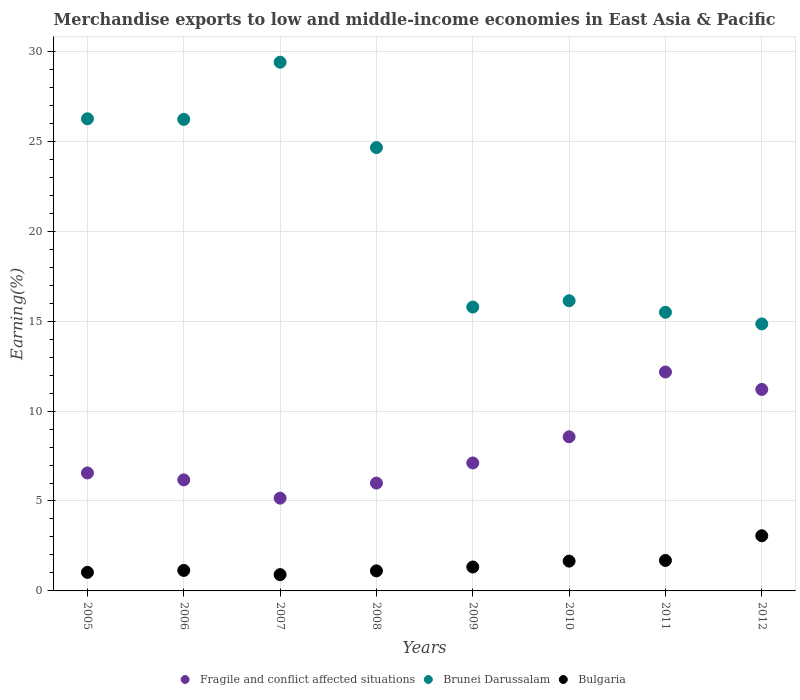How many different coloured dotlines are there?
Provide a succinct answer. 3. Is the number of dotlines equal to the number of legend labels?
Your answer should be very brief. Yes. What is the percentage of amount earned from merchandise exports in Fragile and conflict affected situations in 2011?
Keep it short and to the point. 12.17. Across all years, what is the maximum percentage of amount earned from merchandise exports in Bulgaria?
Your answer should be compact. 3.07. Across all years, what is the minimum percentage of amount earned from merchandise exports in Brunei Darussalam?
Make the answer very short. 14.84. In which year was the percentage of amount earned from merchandise exports in Fragile and conflict affected situations maximum?
Provide a short and direct response. 2011. In which year was the percentage of amount earned from merchandise exports in Fragile and conflict affected situations minimum?
Give a very brief answer. 2007. What is the total percentage of amount earned from merchandise exports in Bulgaria in the graph?
Offer a terse response. 11.94. What is the difference between the percentage of amount earned from merchandise exports in Bulgaria in 2006 and that in 2010?
Give a very brief answer. -0.52. What is the difference between the percentage of amount earned from merchandise exports in Brunei Darussalam in 2009 and the percentage of amount earned from merchandise exports in Fragile and conflict affected situations in 2010?
Your response must be concise. 7.21. What is the average percentage of amount earned from merchandise exports in Brunei Darussalam per year?
Give a very brief answer. 21.1. In the year 2005, what is the difference between the percentage of amount earned from merchandise exports in Bulgaria and percentage of amount earned from merchandise exports in Brunei Darussalam?
Your answer should be compact. -25.22. What is the ratio of the percentage of amount earned from merchandise exports in Brunei Darussalam in 2007 to that in 2011?
Offer a very short reply. 1.9. Is the difference between the percentage of amount earned from merchandise exports in Bulgaria in 2005 and 2006 greater than the difference between the percentage of amount earned from merchandise exports in Brunei Darussalam in 2005 and 2006?
Your answer should be very brief. No. What is the difference between the highest and the second highest percentage of amount earned from merchandise exports in Bulgaria?
Give a very brief answer. 1.37. What is the difference between the highest and the lowest percentage of amount earned from merchandise exports in Bulgaria?
Ensure brevity in your answer.  2.16. Is the sum of the percentage of amount earned from merchandise exports in Fragile and conflict affected situations in 2007 and 2010 greater than the maximum percentage of amount earned from merchandise exports in Bulgaria across all years?
Make the answer very short. Yes. Is it the case that in every year, the sum of the percentage of amount earned from merchandise exports in Bulgaria and percentage of amount earned from merchandise exports in Fragile and conflict affected situations  is greater than the percentage of amount earned from merchandise exports in Brunei Darussalam?
Make the answer very short. No. Is the percentage of amount earned from merchandise exports in Brunei Darussalam strictly greater than the percentage of amount earned from merchandise exports in Bulgaria over the years?
Your response must be concise. Yes. Is the percentage of amount earned from merchandise exports in Bulgaria strictly less than the percentage of amount earned from merchandise exports in Brunei Darussalam over the years?
Your answer should be compact. Yes. How many years are there in the graph?
Your answer should be very brief. 8. Are the values on the major ticks of Y-axis written in scientific E-notation?
Give a very brief answer. No. How many legend labels are there?
Your answer should be very brief. 3. What is the title of the graph?
Offer a very short reply. Merchandise exports to low and middle-income economies in East Asia & Pacific. Does "St. Kitts and Nevis" appear as one of the legend labels in the graph?
Your answer should be very brief. No. What is the label or title of the Y-axis?
Provide a short and direct response. Earning(%). What is the Earning(%) of Fragile and conflict affected situations in 2005?
Provide a short and direct response. 6.56. What is the Earning(%) in Brunei Darussalam in 2005?
Provide a short and direct response. 26.25. What is the Earning(%) of Bulgaria in 2005?
Your answer should be very brief. 1.03. What is the Earning(%) in Fragile and conflict affected situations in 2006?
Your answer should be very brief. 6.17. What is the Earning(%) of Brunei Darussalam in 2006?
Offer a very short reply. 26.22. What is the Earning(%) of Bulgaria in 2006?
Ensure brevity in your answer.  1.14. What is the Earning(%) in Fragile and conflict affected situations in 2007?
Offer a very short reply. 5.16. What is the Earning(%) in Brunei Darussalam in 2007?
Keep it short and to the point. 29.4. What is the Earning(%) in Bulgaria in 2007?
Offer a terse response. 0.91. What is the Earning(%) in Fragile and conflict affected situations in 2008?
Your answer should be compact. 6. What is the Earning(%) in Brunei Darussalam in 2008?
Provide a succinct answer. 24.65. What is the Earning(%) of Bulgaria in 2008?
Make the answer very short. 1.11. What is the Earning(%) in Fragile and conflict affected situations in 2009?
Make the answer very short. 7.12. What is the Earning(%) in Brunei Darussalam in 2009?
Your answer should be very brief. 15.78. What is the Earning(%) of Bulgaria in 2009?
Give a very brief answer. 1.33. What is the Earning(%) in Fragile and conflict affected situations in 2010?
Keep it short and to the point. 8.57. What is the Earning(%) of Brunei Darussalam in 2010?
Ensure brevity in your answer.  16.13. What is the Earning(%) in Bulgaria in 2010?
Make the answer very short. 1.66. What is the Earning(%) of Fragile and conflict affected situations in 2011?
Your answer should be very brief. 12.17. What is the Earning(%) of Brunei Darussalam in 2011?
Provide a succinct answer. 15.49. What is the Earning(%) of Bulgaria in 2011?
Provide a short and direct response. 1.69. What is the Earning(%) in Fragile and conflict affected situations in 2012?
Ensure brevity in your answer.  11.2. What is the Earning(%) in Brunei Darussalam in 2012?
Your answer should be very brief. 14.84. What is the Earning(%) of Bulgaria in 2012?
Provide a succinct answer. 3.07. Across all years, what is the maximum Earning(%) of Fragile and conflict affected situations?
Ensure brevity in your answer.  12.17. Across all years, what is the maximum Earning(%) in Brunei Darussalam?
Offer a terse response. 29.4. Across all years, what is the maximum Earning(%) of Bulgaria?
Give a very brief answer. 3.07. Across all years, what is the minimum Earning(%) in Fragile and conflict affected situations?
Offer a very short reply. 5.16. Across all years, what is the minimum Earning(%) of Brunei Darussalam?
Provide a succinct answer. 14.84. Across all years, what is the minimum Earning(%) of Bulgaria?
Ensure brevity in your answer.  0.91. What is the total Earning(%) of Fragile and conflict affected situations in the graph?
Offer a terse response. 62.94. What is the total Earning(%) of Brunei Darussalam in the graph?
Your response must be concise. 168.77. What is the total Earning(%) in Bulgaria in the graph?
Give a very brief answer. 11.94. What is the difference between the Earning(%) of Fragile and conflict affected situations in 2005 and that in 2006?
Offer a very short reply. 0.39. What is the difference between the Earning(%) in Brunei Darussalam in 2005 and that in 2006?
Your answer should be compact. 0.03. What is the difference between the Earning(%) of Bulgaria in 2005 and that in 2006?
Your answer should be very brief. -0.11. What is the difference between the Earning(%) in Fragile and conflict affected situations in 2005 and that in 2007?
Make the answer very short. 1.4. What is the difference between the Earning(%) in Brunei Darussalam in 2005 and that in 2007?
Provide a short and direct response. -3.15. What is the difference between the Earning(%) of Bulgaria in 2005 and that in 2007?
Provide a succinct answer. 0.13. What is the difference between the Earning(%) of Fragile and conflict affected situations in 2005 and that in 2008?
Ensure brevity in your answer.  0.56. What is the difference between the Earning(%) in Brunei Darussalam in 2005 and that in 2008?
Give a very brief answer. 1.6. What is the difference between the Earning(%) of Bulgaria in 2005 and that in 2008?
Keep it short and to the point. -0.08. What is the difference between the Earning(%) of Fragile and conflict affected situations in 2005 and that in 2009?
Provide a short and direct response. -0.56. What is the difference between the Earning(%) in Brunei Darussalam in 2005 and that in 2009?
Offer a very short reply. 10.47. What is the difference between the Earning(%) of Bulgaria in 2005 and that in 2009?
Ensure brevity in your answer.  -0.3. What is the difference between the Earning(%) in Fragile and conflict affected situations in 2005 and that in 2010?
Make the answer very short. -2.01. What is the difference between the Earning(%) in Brunei Darussalam in 2005 and that in 2010?
Make the answer very short. 10.12. What is the difference between the Earning(%) in Bulgaria in 2005 and that in 2010?
Your answer should be very brief. -0.62. What is the difference between the Earning(%) in Fragile and conflict affected situations in 2005 and that in 2011?
Your response must be concise. -5.61. What is the difference between the Earning(%) of Brunei Darussalam in 2005 and that in 2011?
Provide a short and direct response. 10.76. What is the difference between the Earning(%) of Bulgaria in 2005 and that in 2011?
Your answer should be very brief. -0.66. What is the difference between the Earning(%) in Fragile and conflict affected situations in 2005 and that in 2012?
Your answer should be very brief. -4.64. What is the difference between the Earning(%) of Brunei Darussalam in 2005 and that in 2012?
Your answer should be very brief. 11.41. What is the difference between the Earning(%) in Bulgaria in 2005 and that in 2012?
Offer a terse response. -2.03. What is the difference between the Earning(%) of Fragile and conflict affected situations in 2006 and that in 2007?
Offer a very short reply. 1.02. What is the difference between the Earning(%) in Brunei Darussalam in 2006 and that in 2007?
Your answer should be very brief. -3.18. What is the difference between the Earning(%) of Bulgaria in 2006 and that in 2007?
Provide a short and direct response. 0.23. What is the difference between the Earning(%) in Fragile and conflict affected situations in 2006 and that in 2008?
Make the answer very short. 0.18. What is the difference between the Earning(%) of Brunei Darussalam in 2006 and that in 2008?
Keep it short and to the point. 1.57. What is the difference between the Earning(%) in Bulgaria in 2006 and that in 2008?
Give a very brief answer. 0.03. What is the difference between the Earning(%) in Fragile and conflict affected situations in 2006 and that in 2009?
Provide a succinct answer. -0.94. What is the difference between the Earning(%) in Brunei Darussalam in 2006 and that in 2009?
Your answer should be very brief. 10.43. What is the difference between the Earning(%) in Bulgaria in 2006 and that in 2009?
Your response must be concise. -0.19. What is the difference between the Earning(%) in Fragile and conflict affected situations in 2006 and that in 2010?
Make the answer very short. -2.39. What is the difference between the Earning(%) of Brunei Darussalam in 2006 and that in 2010?
Give a very brief answer. 10.08. What is the difference between the Earning(%) of Bulgaria in 2006 and that in 2010?
Offer a terse response. -0.52. What is the difference between the Earning(%) in Fragile and conflict affected situations in 2006 and that in 2011?
Your answer should be very brief. -6. What is the difference between the Earning(%) in Brunei Darussalam in 2006 and that in 2011?
Ensure brevity in your answer.  10.72. What is the difference between the Earning(%) of Bulgaria in 2006 and that in 2011?
Offer a very short reply. -0.55. What is the difference between the Earning(%) in Fragile and conflict affected situations in 2006 and that in 2012?
Your response must be concise. -5.03. What is the difference between the Earning(%) in Brunei Darussalam in 2006 and that in 2012?
Make the answer very short. 11.37. What is the difference between the Earning(%) in Bulgaria in 2006 and that in 2012?
Make the answer very short. -1.93. What is the difference between the Earning(%) of Fragile and conflict affected situations in 2007 and that in 2008?
Make the answer very short. -0.84. What is the difference between the Earning(%) of Brunei Darussalam in 2007 and that in 2008?
Your answer should be very brief. 4.75. What is the difference between the Earning(%) of Bulgaria in 2007 and that in 2008?
Offer a terse response. -0.21. What is the difference between the Earning(%) in Fragile and conflict affected situations in 2007 and that in 2009?
Offer a very short reply. -1.96. What is the difference between the Earning(%) of Brunei Darussalam in 2007 and that in 2009?
Offer a very short reply. 13.61. What is the difference between the Earning(%) in Bulgaria in 2007 and that in 2009?
Provide a short and direct response. -0.42. What is the difference between the Earning(%) in Fragile and conflict affected situations in 2007 and that in 2010?
Your answer should be very brief. -3.41. What is the difference between the Earning(%) of Brunei Darussalam in 2007 and that in 2010?
Give a very brief answer. 13.26. What is the difference between the Earning(%) in Bulgaria in 2007 and that in 2010?
Your answer should be compact. -0.75. What is the difference between the Earning(%) of Fragile and conflict affected situations in 2007 and that in 2011?
Your response must be concise. -7.01. What is the difference between the Earning(%) of Brunei Darussalam in 2007 and that in 2011?
Give a very brief answer. 13.9. What is the difference between the Earning(%) of Bulgaria in 2007 and that in 2011?
Make the answer very short. -0.79. What is the difference between the Earning(%) in Fragile and conflict affected situations in 2007 and that in 2012?
Provide a succinct answer. -6.04. What is the difference between the Earning(%) of Brunei Darussalam in 2007 and that in 2012?
Give a very brief answer. 14.55. What is the difference between the Earning(%) in Bulgaria in 2007 and that in 2012?
Your response must be concise. -2.16. What is the difference between the Earning(%) of Fragile and conflict affected situations in 2008 and that in 2009?
Give a very brief answer. -1.12. What is the difference between the Earning(%) in Brunei Darussalam in 2008 and that in 2009?
Make the answer very short. 8.87. What is the difference between the Earning(%) in Bulgaria in 2008 and that in 2009?
Provide a short and direct response. -0.22. What is the difference between the Earning(%) in Fragile and conflict affected situations in 2008 and that in 2010?
Make the answer very short. -2.57. What is the difference between the Earning(%) in Brunei Darussalam in 2008 and that in 2010?
Make the answer very short. 8.51. What is the difference between the Earning(%) in Bulgaria in 2008 and that in 2010?
Provide a succinct answer. -0.54. What is the difference between the Earning(%) of Fragile and conflict affected situations in 2008 and that in 2011?
Ensure brevity in your answer.  -6.18. What is the difference between the Earning(%) of Brunei Darussalam in 2008 and that in 2011?
Make the answer very short. 9.16. What is the difference between the Earning(%) in Bulgaria in 2008 and that in 2011?
Provide a succinct answer. -0.58. What is the difference between the Earning(%) of Fragile and conflict affected situations in 2008 and that in 2012?
Ensure brevity in your answer.  -5.21. What is the difference between the Earning(%) in Brunei Darussalam in 2008 and that in 2012?
Make the answer very short. 9.8. What is the difference between the Earning(%) in Bulgaria in 2008 and that in 2012?
Your response must be concise. -1.95. What is the difference between the Earning(%) of Fragile and conflict affected situations in 2009 and that in 2010?
Ensure brevity in your answer.  -1.45. What is the difference between the Earning(%) in Brunei Darussalam in 2009 and that in 2010?
Ensure brevity in your answer.  -0.35. What is the difference between the Earning(%) of Bulgaria in 2009 and that in 2010?
Your response must be concise. -0.33. What is the difference between the Earning(%) of Fragile and conflict affected situations in 2009 and that in 2011?
Offer a terse response. -5.06. What is the difference between the Earning(%) of Brunei Darussalam in 2009 and that in 2011?
Your answer should be compact. 0.29. What is the difference between the Earning(%) of Bulgaria in 2009 and that in 2011?
Keep it short and to the point. -0.36. What is the difference between the Earning(%) of Fragile and conflict affected situations in 2009 and that in 2012?
Keep it short and to the point. -4.09. What is the difference between the Earning(%) in Brunei Darussalam in 2009 and that in 2012?
Offer a terse response. 0.94. What is the difference between the Earning(%) in Bulgaria in 2009 and that in 2012?
Keep it short and to the point. -1.74. What is the difference between the Earning(%) in Fragile and conflict affected situations in 2010 and that in 2011?
Give a very brief answer. -3.6. What is the difference between the Earning(%) in Brunei Darussalam in 2010 and that in 2011?
Your answer should be compact. 0.64. What is the difference between the Earning(%) of Bulgaria in 2010 and that in 2011?
Make the answer very short. -0.04. What is the difference between the Earning(%) of Fragile and conflict affected situations in 2010 and that in 2012?
Your answer should be very brief. -2.63. What is the difference between the Earning(%) of Brunei Darussalam in 2010 and that in 2012?
Your response must be concise. 1.29. What is the difference between the Earning(%) of Bulgaria in 2010 and that in 2012?
Your answer should be very brief. -1.41. What is the difference between the Earning(%) of Fragile and conflict affected situations in 2011 and that in 2012?
Keep it short and to the point. 0.97. What is the difference between the Earning(%) in Brunei Darussalam in 2011 and that in 2012?
Keep it short and to the point. 0.65. What is the difference between the Earning(%) in Bulgaria in 2011 and that in 2012?
Offer a terse response. -1.37. What is the difference between the Earning(%) in Fragile and conflict affected situations in 2005 and the Earning(%) in Brunei Darussalam in 2006?
Offer a terse response. -19.66. What is the difference between the Earning(%) in Fragile and conflict affected situations in 2005 and the Earning(%) in Bulgaria in 2006?
Provide a short and direct response. 5.42. What is the difference between the Earning(%) of Brunei Darussalam in 2005 and the Earning(%) of Bulgaria in 2006?
Offer a very short reply. 25.11. What is the difference between the Earning(%) in Fragile and conflict affected situations in 2005 and the Earning(%) in Brunei Darussalam in 2007?
Offer a very short reply. -22.84. What is the difference between the Earning(%) in Fragile and conflict affected situations in 2005 and the Earning(%) in Bulgaria in 2007?
Provide a short and direct response. 5.65. What is the difference between the Earning(%) of Brunei Darussalam in 2005 and the Earning(%) of Bulgaria in 2007?
Provide a short and direct response. 25.35. What is the difference between the Earning(%) in Fragile and conflict affected situations in 2005 and the Earning(%) in Brunei Darussalam in 2008?
Provide a short and direct response. -18.09. What is the difference between the Earning(%) in Fragile and conflict affected situations in 2005 and the Earning(%) in Bulgaria in 2008?
Make the answer very short. 5.44. What is the difference between the Earning(%) in Brunei Darussalam in 2005 and the Earning(%) in Bulgaria in 2008?
Give a very brief answer. 25.14. What is the difference between the Earning(%) of Fragile and conflict affected situations in 2005 and the Earning(%) of Brunei Darussalam in 2009?
Your answer should be compact. -9.22. What is the difference between the Earning(%) in Fragile and conflict affected situations in 2005 and the Earning(%) in Bulgaria in 2009?
Your answer should be compact. 5.23. What is the difference between the Earning(%) in Brunei Darussalam in 2005 and the Earning(%) in Bulgaria in 2009?
Provide a short and direct response. 24.92. What is the difference between the Earning(%) in Fragile and conflict affected situations in 2005 and the Earning(%) in Brunei Darussalam in 2010?
Keep it short and to the point. -9.57. What is the difference between the Earning(%) of Fragile and conflict affected situations in 2005 and the Earning(%) of Bulgaria in 2010?
Your response must be concise. 4.9. What is the difference between the Earning(%) of Brunei Darussalam in 2005 and the Earning(%) of Bulgaria in 2010?
Ensure brevity in your answer.  24.59. What is the difference between the Earning(%) of Fragile and conflict affected situations in 2005 and the Earning(%) of Brunei Darussalam in 2011?
Provide a short and direct response. -8.93. What is the difference between the Earning(%) of Fragile and conflict affected situations in 2005 and the Earning(%) of Bulgaria in 2011?
Your response must be concise. 4.87. What is the difference between the Earning(%) in Brunei Darussalam in 2005 and the Earning(%) in Bulgaria in 2011?
Ensure brevity in your answer.  24.56. What is the difference between the Earning(%) in Fragile and conflict affected situations in 2005 and the Earning(%) in Brunei Darussalam in 2012?
Make the answer very short. -8.29. What is the difference between the Earning(%) in Fragile and conflict affected situations in 2005 and the Earning(%) in Bulgaria in 2012?
Your answer should be compact. 3.49. What is the difference between the Earning(%) of Brunei Darussalam in 2005 and the Earning(%) of Bulgaria in 2012?
Give a very brief answer. 23.18. What is the difference between the Earning(%) of Fragile and conflict affected situations in 2006 and the Earning(%) of Brunei Darussalam in 2007?
Your answer should be compact. -23.22. What is the difference between the Earning(%) in Fragile and conflict affected situations in 2006 and the Earning(%) in Bulgaria in 2007?
Offer a very short reply. 5.27. What is the difference between the Earning(%) of Brunei Darussalam in 2006 and the Earning(%) of Bulgaria in 2007?
Keep it short and to the point. 25.31. What is the difference between the Earning(%) of Fragile and conflict affected situations in 2006 and the Earning(%) of Brunei Darussalam in 2008?
Offer a terse response. -18.47. What is the difference between the Earning(%) in Fragile and conflict affected situations in 2006 and the Earning(%) in Bulgaria in 2008?
Offer a very short reply. 5.06. What is the difference between the Earning(%) of Brunei Darussalam in 2006 and the Earning(%) of Bulgaria in 2008?
Your answer should be compact. 25.1. What is the difference between the Earning(%) of Fragile and conflict affected situations in 2006 and the Earning(%) of Brunei Darussalam in 2009?
Your answer should be compact. -9.61. What is the difference between the Earning(%) in Fragile and conflict affected situations in 2006 and the Earning(%) in Bulgaria in 2009?
Keep it short and to the point. 4.84. What is the difference between the Earning(%) of Brunei Darussalam in 2006 and the Earning(%) of Bulgaria in 2009?
Offer a very short reply. 24.89. What is the difference between the Earning(%) of Fragile and conflict affected situations in 2006 and the Earning(%) of Brunei Darussalam in 2010?
Your answer should be very brief. -9.96. What is the difference between the Earning(%) of Fragile and conflict affected situations in 2006 and the Earning(%) of Bulgaria in 2010?
Your answer should be very brief. 4.52. What is the difference between the Earning(%) of Brunei Darussalam in 2006 and the Earning(%) of Bulgaria in 2010?
Provide a short and direct response. 24.56. What is the difference between the Earning(%) in Fragile and conflict affected situations in 2006 and the Earning(%) in Brunei Darussalam in 2011?
Your answer should be compact. -9.32. What is the difference between the Earning(%) in Fragile and conflict affected situations in 2006 and the Earning(%) in Bulgaria in 2011?
Your answer should be very brief. 4.48. What is the difference between the Earning(%) of Brunei Darussalam in 2006 and the Earning(%) of Bulgaria in 2011?
Your response must be concise. 24.52. What is the difference between the Earning(%) in Fragile and conflict affected situations in 2006 and the Earning(%) in Brunei Darussalam in 2012?
Ensure brevity in your answer.  -8.67. What is the difference between the Earning(%) in Fragile and conflict affected situations in 2006 and the Earning(%) in Bulgaria in 2012?
Your answer should be compact. 3.11. What is the difference between the Earning(%) in Brunei Darussalam in 2006 and the Earning(%) in Bulgaria in 2012?
Make the answer very short. 23.15. What is the difference between the Earning(%) of Fragile and conflict affected situations in 2007 and the Earning(%) of Brunei Darussalam in 2008?
Provide a short and direct response. -19.49. What is the difference between the Earning(%) of Fragile and conflict affected situations in 2007 and the Earning(%) of Bulgaria in 2008?
Offer a very short reply. 4.04. What is the difference between the Earning(%) of Brunei Darussalam in 2007 and the Earning(%) of Bulgaria in 2008?
Provide a short and direct response. 28.28. What is the difference between the Earning(%) of Fragile and conflict affected situations in 2007 and the Earning(%) of Brunei Darussalam in 2009?
Your answer should be compact. -10.62. What is the difference between the Earning(%) of Fragile and conflict affected situations in 2007 and the Earning(%) of Bulgaria in 2009?
Your response must be concise. 3.83. What is the difference between the Earning(%) in Brunei Darussalam in 2007 and the Earning(%) in Bulgaria in 2009?
Make the answer very short. 28.07. What is the difference between the Earning(%) of Fragile and conflict affected situations in 2007 and the Earning(%) of Brunei Darussalam in 2010?
Ensure brevity in your answer.  -10.98. What is the difference between the Earning(%) in Fragile and conflict affected situations in 2007 and the Earning(%) in Bulgaria in 2010?
Your answer should be compact. 3.5. What is the difference between the Earning(%) of Brunei Darussalam in 2007 and the Earning(%) of Bulgaria in 2010?
Offer a very short reply. 27.74. What is the difference between the Earning(%) in Fragile and conflict affected situations in 2007 and the Earning(%) in Brunei Darussalam in 2011?
Offer a very short reply. -10.33. What is the difference between the Earning(%) of Fragile and conflict affected situations in 2007 and the Earning(%) of Bulgaria in 2011?
Give a very brief answer. 3.46. What is the difference between the Earning(%) in Brunei Darussalam in 2007 and the Earning(%) in Bulgaria in 2011?
Your response must be concise. 27.7. What is the difference between the Earning(%) of Fragile and conflict affected situations in 2007 and the Earning(%) of Brunei Darussalam in 2012?
Make the answer very short. -9.69. What is the difference between the Earning(%) in Fragile and conflict affected situations in 2007 and the Earning(%) in Bulgaria in 2012?
Provide a short and direct response. 2.09. What is the difference between the Earning(%) in Brunei Darussalam in 2007 and the Earning(%) in Bulgaria in 2012?
Keep it short and to the point. 26.33. What is the difference between the Earning(%) in Fragile and conflict affected situations in 2008 and the Earning(%) in Brunei Darussalam in 2009?
Provide a short and direct response. -9.79. What is the difference between the Earning(%) of Fragile and conflict affected situations in 2008 and the Earning(%) of Bulgaria in 2009?
Make the answer very short. 4.67. What is the difference between the Earning(%) of Brunei Darussalam in 2008 and the Earning(%) of Bulgaria in 2009?
Your answer should be compact. 23.32. What is the difference between the Earning(%) of Fragile and conflict affected situations in 2008 and the Earning(%) of Brunei Darussalam in 2010?
Offer a terse response. -10.14. What is the difference between the Earning(%) of Fragile and conflict affected situations in 2008 and the Earning(%) of Bulgaria in 2010?
Keep it short and to the point. 4.34. What is the difference between the Earning(%) in Brunei Darussalam in 2008 and the Earning(%) in Bulgaria in 2010?
Make the answer very short. 22.99. What is the difference between the Earning(%) of Fragile and conflict affected situations in 2008 and the Earning(%) of Brunei Darussalam in 2011?
Your response must be concise. -9.5. What is the difference between the Earning(%) of Fragile and conflict affected situations in 2008 and the Earning(%) of Bulgaria in 2011?
Ensure brevity in your answer.  4.3. What is the difference between the Earning(%) in Brunei Darussalam in 2008 and the Earning(%) in Bulgaria in 2011?
Make the answer very short. 22.95. What is the difference between the Earning(%) of Fragile and conflict affected situations in 2008 and the Earning(%) of Brunei Darussalam in 2012?
Your answer should be compact. -8.85. What is the difference between the Earning(%) of Fragile and conflict affected situations in 2008 and the Earning(%) of Bulgaria in 2012?
Make the answer very short. 2.93. What is the difference between the Earning(%) in Brunei Darussalam in 2008 and the Earning(%) in Bulgaria in 2012?
Your response must be concise. 21.58. What is the difference between the Earning(%) in Fragile and conflict affected situations in 2009 and the Earning(%) in Brunei Darussalam in 2010?
Make the answer very short. -9.02. What is the difference between the Earning(%) in Fragile and conflict affected situations in 2009 and the Earning(%) in Bulgaria in 2010?
Make the answer very short. 5.46. What is the difference between the Earning(%) of Brunei Darussalam in 2009 and the Earning(%) of Bulgaria in 2010?
Make the answer very short. 14.13. What is the difference between the Earning(%) in Fragile and conflict affected situations in 2009 and the Earning(%) in Brunei Darussalam in 2011?
Your answer should be very brief. -8.38. What is the difference between the Earning(%) in Fragile and conflict affected situations in 2009 and the Earning(%) in Bulgaria in 2011?
Keep it short and to the point. 5.42. What is the difference between the Earning(%) in Brunei Darussalam in 2009 and the Earning(%) in Bulgaria in 2011?
Provide a short and direct response. 14.09. What is the difference between the Earning(%) in Fragile and conflict affected situations in 2009 and the Earning(%) in Brunei Darussalam in 2012?
Your response must be concise. -7.73. What is the difference between the Earning(%) in Fragile and conflict affected situations in 2009 and the Earning(%) in Bulgaria in 2012?
Offer a very short reply. 4.05. What is the difference between the Earning(%) in Brunei Darussalam in 2009 and the Earning(%) in Bulgaria in 2012?
Make the answer very short. 12.72. What is the difference between the Earning(%) of Fragile and conflict affected situations in 2010 and the Earning(%) of Brunei Darussalam in 2011?
Your answer should be compact. -6.92. What is the difference between the Earning(%) of Fragile and conflict affected situations in 2010 and the Earning(%) of Bulgaria in 2011?
Provide a short and direct response. 6.87. What is the difference between the Earning(%) of Brunei Darussalam in 2010 and the Earning(%) of Bulgaria in 2011?
Your response must be concise. 14.44. What is the difference between the Earning(%) in Fragile and conflict affected situations in 2010 and the Earning(%) in Brunei Darussalam in 2012?
Make the answer very short. -6.28. What is the difference between the Earning(%) in Fragile and conflict affected situations in 2010 and the Earning(%) in Bulgaria in 2012?
Make the answer very short. 5.5. What is the difference between the Earning(%) of Brunei Darussalam in 2010 and the Earning(%) of Bulgaria in 2012?
Keep it short and to the point. 13.07. What is the difference between the Earning(%) in Fragile and conflict affected situations in 2011 and the Earning(%) in Brunei Darussalam in 2012?
Offer a very short reply. -2.67. What is the difference between the Earning(%) of Fragile and conflict affected situations in 2011 and the Earning(%) of Bulgaria in 2012?
Make the answer very short. 9.1. What is the difference between the Earning(%) in Brunei Darussalam in 2011 and the Earning(%) in Bulgaria in 2012?
Ensure brevity in your answer.  12.42. What is the average Earning(%) of Fragile and conflict affected situations per year?
Provide a short and direct response. 7.87. What is the average Earning(%) of Brunei Darussalam per year?
Ensure brevity in your answer.  21.1. What is the average Earning(%) in Bulgaria per year?
Offer a terse response. 1.49. In the year 2005, what is the difference between the Earning(%) in Fragile and conflict affected situations and Earning(%) in Brunei Darussalam?
Give a very brief answer. -19.69. In the year 2005, what is the difference between the Earning(%) of Fragile and conflict affected situations and Earning(%) of Bulgaria?
Make the answer very short. 5.53. In the year 2005, what is the difference between the Earning(%) of Brunei Darussalam and Earning(%) of Bulgaria?
Keep it short and to the point. 25.22. In the year 2006, what is the difference between the Earning(%) in Fragile and conflict affected situations and Earning(%) in Brunei Darussalam?
Make the answer very short. -20.04. In the year 2006, what is the difference between the Earning(%) in Fragile and conflict affected situations and Earning(%) in Bulgaria?
Offer a terse response. 5.03. In the year 2006, what is the difference between the Earning(%) of Brunei Darussalam and Earning(%) of Bulgaria?
Provide a succinct answer. 25.08. In the year 2007, what is the difference between the Earning(%) in Fragile and conflict affected situations and Earning(%) in Brunei Darussalam?
Ensure brevity in your answer.  -24.24. In the year 2007, what is the difference between the Earning(%) of Fragile and conflict affected situations and Earning(%) of Bulgaria?
Your answer should be very brief. 4.25. In the year 2007, what is the difference between the Earning(%) in Brunei Darussalam and Earning(%) in Bulgaria?
Ensure brevity in your answer.  28.49. In the year 2008, what is the difference between the Earning(%) in Fragile and conflict affected situations and Earning(%) in Brunei Darussalam?
Offer a terse response. -18.65. In the year 2008, what is the difference between the Earning(%) of Fragile and conflict affected situations and Earning(%) of Bulgaria?
Your response must be concise. 4.88. In the year 2008, what is the difference between the Earning(%) in Brunei Darussalam and Earning(%) in Bulgaria?
Provide a succinct answer. 23.53. In the year 2009, what is the difference between the Earning(%) of Fragile and conflict affected situations and Earning(%) of Brunei Darussalam?
Keep it short and to the point. -8.67. In the year 2009, what is the difference between the Earning(%) in Fragile and conflict affected situations and Earning(%) in Bulgaria?
Ensure brevity in your answer.  5.79. In the year 2009, what is the difference between the Earning(%) in Brunei Darussalam and Earning(%) in Bulgaria?
Your answer should be very brief. 14.45. In the year 2010, what is the difference between the Earning(%) in Fragile and conflict affected situations and Earning(%) in Brunei Darussalam?
Offer a very short reply. -7.57. In the year 2010, what is the difference between the Earning(%) in Fragile and conflict affected situations and Earning(%) in Bulgaria?
Provide a short and direct response. 6.91. In the year 2010, what is the difference between the Earning(%) of Brunei Darussalam and Earning(%) of Bulgaria?
Your response must be concise. 14.48. In the year 2011, what is the difference between the Earning(%) in Fragile and conflict affected situations and Earning(%) in Brunei Darussalam?
Offer a very short reply. -3.32. In the year 2011, what is the difference between the Earning(%) in Fragile and conflict affected situations and Earning(%) in Bulgaria?
Keep it short and to the point. 10.48. In the year 2011, what is the difference between the Earning(%) of Brunei Darussalam and Earning(%) of Bulgaria?
Provide a succinct answer. 13.8. In the year 2012, what is the difference between the Earning(%) in Fragile and conflict affected situations and Earning(%) in Brunei Darussalam?
Your response must be concise. -3.64. In the year 2012, what is the difference between the Earning(%) of Fragile and conflict affected situations and Earning(%) of Bulgaria?
Keep it short and to the point. 8.13. In the year 2012, what is the difference between the Earning(%) of Brunei Darussalam and Earning(%) of Bulgaria?
Make the answer very short. 11.78. What is the ratio of the Earning(%) in Fragile and conflict affected situations in 2005 to that in 2006?
Offer a terse response. 1.06. What is the ratio of the Earning(%) in Bulgaria in 2005 to that in 2006?
Keep it short and to the point. 0.91. What is the ratio of the Earning(%) in Fragile and conflict affected situations in 2005 to that in 2007?
Your answer should be compact. 1.27. What is the ratio of the Earning(%) of Brunei Darussalam in 2005 to that in 2007?
Provide a short and direct response. 0.89. What is the ratio of the Earning(%) in Bulgaria in 2005 to that in 2007?
Make the answer very short. 1.14. What is the ratio of the Earning(%) of Fragile and conflict affected situations in 2005 to that in 2008?
Keep it short and to the point. 1.09. What is the ratio of the Earning(%) of Brunei Darussalam in 2005 to that in 2008?
Provide a succinct answer. 1.06. What is the ratio of the Earning(%) in Bulgaria in 2005 to that in 2008?
Offer a terse response. 0.93. What is the ratio of the Earning(%) of Fragile and conflict affected situations in 2005 to that in 2009?
Your answer should be compact. 0.92. What is the ratio of the Earning(%) in Brunei Darussalam in 2005 to that in 2009?
Provide a succinct answer. 1.66. What is the ratio of the Earning(%) of Bulgaria in 2005 to that in 2009?
Make the answer very short. 0.78. What is the ratio of the Earning(%) in Fragile and conflict affected situations in 2005 to that in 2010?
Offer a terse response. 0.77. What is the ratio of the Earning(%) of Brunei Darussalam in 2005 to that in 2010?
Make the answer very short. 1.63. What is the ratio of the Earning(%) in Bulgaria in 2005 to that in 2010?
Provide a short and direct response. 0.62. What is the ratio of the Earning(%) of Fragile and conflict affected situations in 2005 to that in 2011?
Make the answer very short. 0.54. What is the ratio of the Earning(%) in Brunei Darussalam in 2005 to that in 2011?
Your answer should be very brief. 1.69. What is the ratio of the Earning(%) of Bulgaria in 2005 to that in 2011?
Your answer should be very brief. 0.61. What is the ratio of the Earning(%) of Fragile and conflict affected situations in 2005 to that in 2012?
Your answer should be compact. 0.59. What is the ratio of the Earning(%) of Brunei Darussalam in 2005 to that in 2012?
Give a very brief answer. 1.77. What is the ratio of the Earning(%) in Bulgaria in 2005 to that in 2012?
Keep it short and to the point. 0.34. What is the ratio of the Earning(%) in Fragile and conflict affected situations in 2006 to that in 2007?
Make the answer very short. 1.2. What is the ratio of the Earning(%) of Brunei Darussalam in 2006 to that in 2007?
Your answer should be compact. 0.89. What is the ratio of the Earning(%) in Bulgaria in 2006 to that in 2007?
Provide a short and direct response. 1.26. What is the ratio of the Earning(%) in Fragile and conflict affected situations in 2006 to that in 2008?
Your response must be concise. 1.03. What is the ratio of the Earning(%) of Brunei Darussalam in 2006 to that in 2008?
Give a very brief answer. 1.06. What is the ratio of the Earning(%) in Bulgaria in 2006 to that in 2008?
Ensure brevity in your answer.  1.02. What is the ratio of the Earning(%) in Fragile and conflict affected situations in 2006 to that in 2009?
Your answer should be very brief. 0.87. What is the ratio of the Earning(%) of Brunei Darussalam in 2006 to that in 2009?
Provide a succinct answer. 1.66. What is the ratio of the Earning(%) in Bulgaria in 2006 to that in 2009?
Offer a very short reply. 0.86. What is the ratio of the Earning(%) of Fragile and conflict affected situations in 2006 to that in 2010?
Your answer should be compact. 0.72. What is the ratio of the Earning(%) in Brunei Darussalam in 2006 to that in 2010?
Offer a terse response. 1.62. What is the ratio of the Earning(%) in Bulgaria in 2006 to that in 2010?
Your answer should be compact. 0.69. What is the ratio of the Earning(%) in Fragile and conflict affected situations in 2006 to that in 2011?
Give a very brief answer. 0.51. What is the ratio of the Earning(%) in Brunei Darussalam in 2006 to that in 2011?
Make the answer very short. 1.69. What is the ratio of the Earning(%) of Bulgaria in 2006 to that in 2011?
Offer a very short reply. 0.67. What is the ratio of the Earning(%) of Fragile and conflict affected situations in 2006 to that in 2012?
Provide a short and direct response. 0.55. What is the ratio of the Earning(%) in Brunei Darussalam in 2006 to that in 2012?
Your response must be concise. 1.77. What is the ratio of the Earning(%) of Bulgaria in 2006 to that in 2012?
Ensure brevity in your answer.  0.37. What is the ratio of the Earning(%) of Fragile and conflict affected situations in 2007 to that in 2008?
Your answer should be compact. 0.86. What is the ratio of the Earning(%) in Brunei Darussalam in 2007 to that in 2008?
Ensure brevity in your answer.  1.19. What is the ratio of the Earning(%) of Bulgaria in 2007 to that in 2008?
Make the answer very short. 0.81. What is the ratio of the Earning(%) in Fragile and conflict affected situations in 2007 to that in 2009?
Make the answer very short. 0.72. What is the ratio of the Earning(%) in Brunei Darussalam in 2007 to that in 2009?
Provide a succinct answer. 1.86. What is the ratio of the Earning(%) in Bulgaria in 2007 to that in 2009?
Keep it short and to the point. 0.68. What is the ratio of the Earning(%) of Fragile and conflict affected situations in 2007 to that in 2010?
Make the answer very short. 0.6. What is the ratio of the Earning(%) of Brunei Darussalam in 2007 to that in 2010?
Provide a short and direct response. 1.82. What is the ratio of the Earning(%) in Bulgaria in 2007 to that in 2010?
Your answer should be compact. 0.55. What is the ratio of the Earning(%) in Fragile and conflict affected situations in 2007 to that in 2011?
Your answer should be compact. 0.42. What is the ratio of the Earning(%) in Brunei Darussalam in 2007 to that in 2011?
Offer a terse response. 1.9. What is the ratio of the Earning(%) of Bulgaria in 2007 to that in 2011?
Your answer should be very brief. 0.53. What is the ratio of the Earning(%) of Fragile and conflict affected situations in 2007 to that in 2012?
Provide a succinct answer. 0.46. What is the ratio of the Earning(%) of Brunei Darussalam in 2007 to that in 2012?
Provide a succinct answer. 1.98. What is the ratio of the Earning(%) in Bulgaria in 2007 to that in 2012?
Keep it short and to the point. 0.3. What is the ratio of the Earning(%) of Fragile and conflict affected situations in 2008 to that in 2009?
Give a very brief answer. 0.84. What is the ratio of the Earning(%) in Brunei Darussalam in 2008 to that in 2009?
Provide a short and direct response. 1.56. What is the ratio of the Earning(%) in Bulgaria in 2008 to that in 2009?
Make the answer very short. 0.84. What is the ratio of the Earning(%) of Fragile and conflict affected situations in 2008 to that in 2010?
Offer a terse response. 0.7. What is the ratio of the Earning(%) in Brunei Darussalam in 2008 to that in 2010?
Make the answer very short. 1.53. What is the ratio of the Earning(%) in Bulgaria in 2008 to that in 2010?
Your answer should be compact. 0.67. What is the ratio of the Earning(%) in Fragile and conflict affected situations in 2008 to that in 2011?
Your response must be concise. 0.49. What is the ratio of the Earning(%) of Brunei Darussalam in 2008 to that in 2011?
Ensure brevity in your answer.  1.59. What is the ratio of the Earning(%) of Bulgaria in 2008 to that in 2011?
Your answer should be very brief. 0.66. What is the ratio of the Earning(%) of Fragile and conflict affected situations in 2008 to that in 2012?
Offer a very short reply. 0.54. What is the ratio of the Earning(%) in Brunei Darussalam in 2008 to that in 2012?
Keep it short and to the point. 1.66. What is the ratio of the Earning(%) of Bulgaria in 2008 to that in 2012?
Provide a succinct answer. 0.36. What is the ratio of the Earning(%) of Fragile and conflict affected situations in 2009 to that in 2010?
Your answer should be very brief. 0.83. What is the ratio of the Earning(%) of Brunei Darussalam in 2009 to that in 2010?
Keep it short and to the point. 0.98. What is the ratio of the Earning(%) in Bulgaria in 2009 to that in 2010?
Your answer should be compact. 0.8. What is the ratio of the Earning(%) of Fragile and conflict affected situations in 2009 to that in 2011?
Make the answer very short. 0.58. What is the ratio of the Earning(%) in Brunei Darussalam in 2009 to that in 2011?
Offer a terse response. 1.02. What is the ratio of the Earning(%) in Bulgaria in 2009 to that in 2011?
Offer a very short reply. 0.79. What is the ratio of the Earning(%) of Fragile and conflict affected situations in 2009 to that in 2012?
Give a very brief answer. 0.64. What is the ratio of the Earning(%) in Brunei Darussalam in 2009 to that in 2012?
Make the answer very short. 1.06. What is the ratio of the Earning(%) of Bulgaria in 2009 to that in 2012?
Offer a very short reply. 0.43. What is the ratio of the Earning(%) of Fragile and conflict affected situations in 2010 to that in 2011?
Your response must be concise. 0.7. What is the ratio of the Earning(%) in Brunei Darussalam in 2010 to that in 2011?
Keep it short and to the point. 1.04. What is the ratio of the Earning(%) of Bulgaria in 2010 to that in 2011?
Provide a short and direct response. 0.98. What is the ratio of the Earning(%) of Fragile and conflict affected situations in 2010 to that in 2012?
Provide a short and direct response. 0.76. What is the ratio of the Earning(%) in Brunei Darussalam in 2010 to that in 2012?
Provide a succinct answer. 1.09. What is the ratio of the Earning(%) of Bulgaria in 2010 to that in 2012?
Keep it short and to the point. 0.54. What is the ratio of the Earning(%) of Fragile and conflict affected situations in 2011 to that in 2012?
Ensure brevity in your answer.  1.09. What is the ratio of the Earning(%) of Brunei Darussalam in 2011 to that in 2012?
Give a very brief answer. 1.04. What is the ratio of the Earning(%) of Bulgaria in 2011 to that in 2012?
Ensure brevity in your answer.  0.55. What is the difference between the highest and the second highest Earning(%) of Fragile and conflict affected situations?
Ensure brevity in your answer.  0.97. What is the difference between the highest and the second highest Earning(%) in Brunei Darussalam?
Offer a terse response. 3.15. What is the difference between the highest and the second highest Earning(%) of Bulgaria?
Offer a very short reply. 1.37. What is the difference between the highest and the lowest Earning(%) of Fragile and conflict affected situations?
Offer a terse response. 7.01. What is the difference between the highest and the lowest Earning(%) of Brunei Darussalam?
Your answer should be compact. 14.55. What is the difference between the highest and the lowest Earning(%) of Bulgaria?
Give a very brief answer. 2.16. 